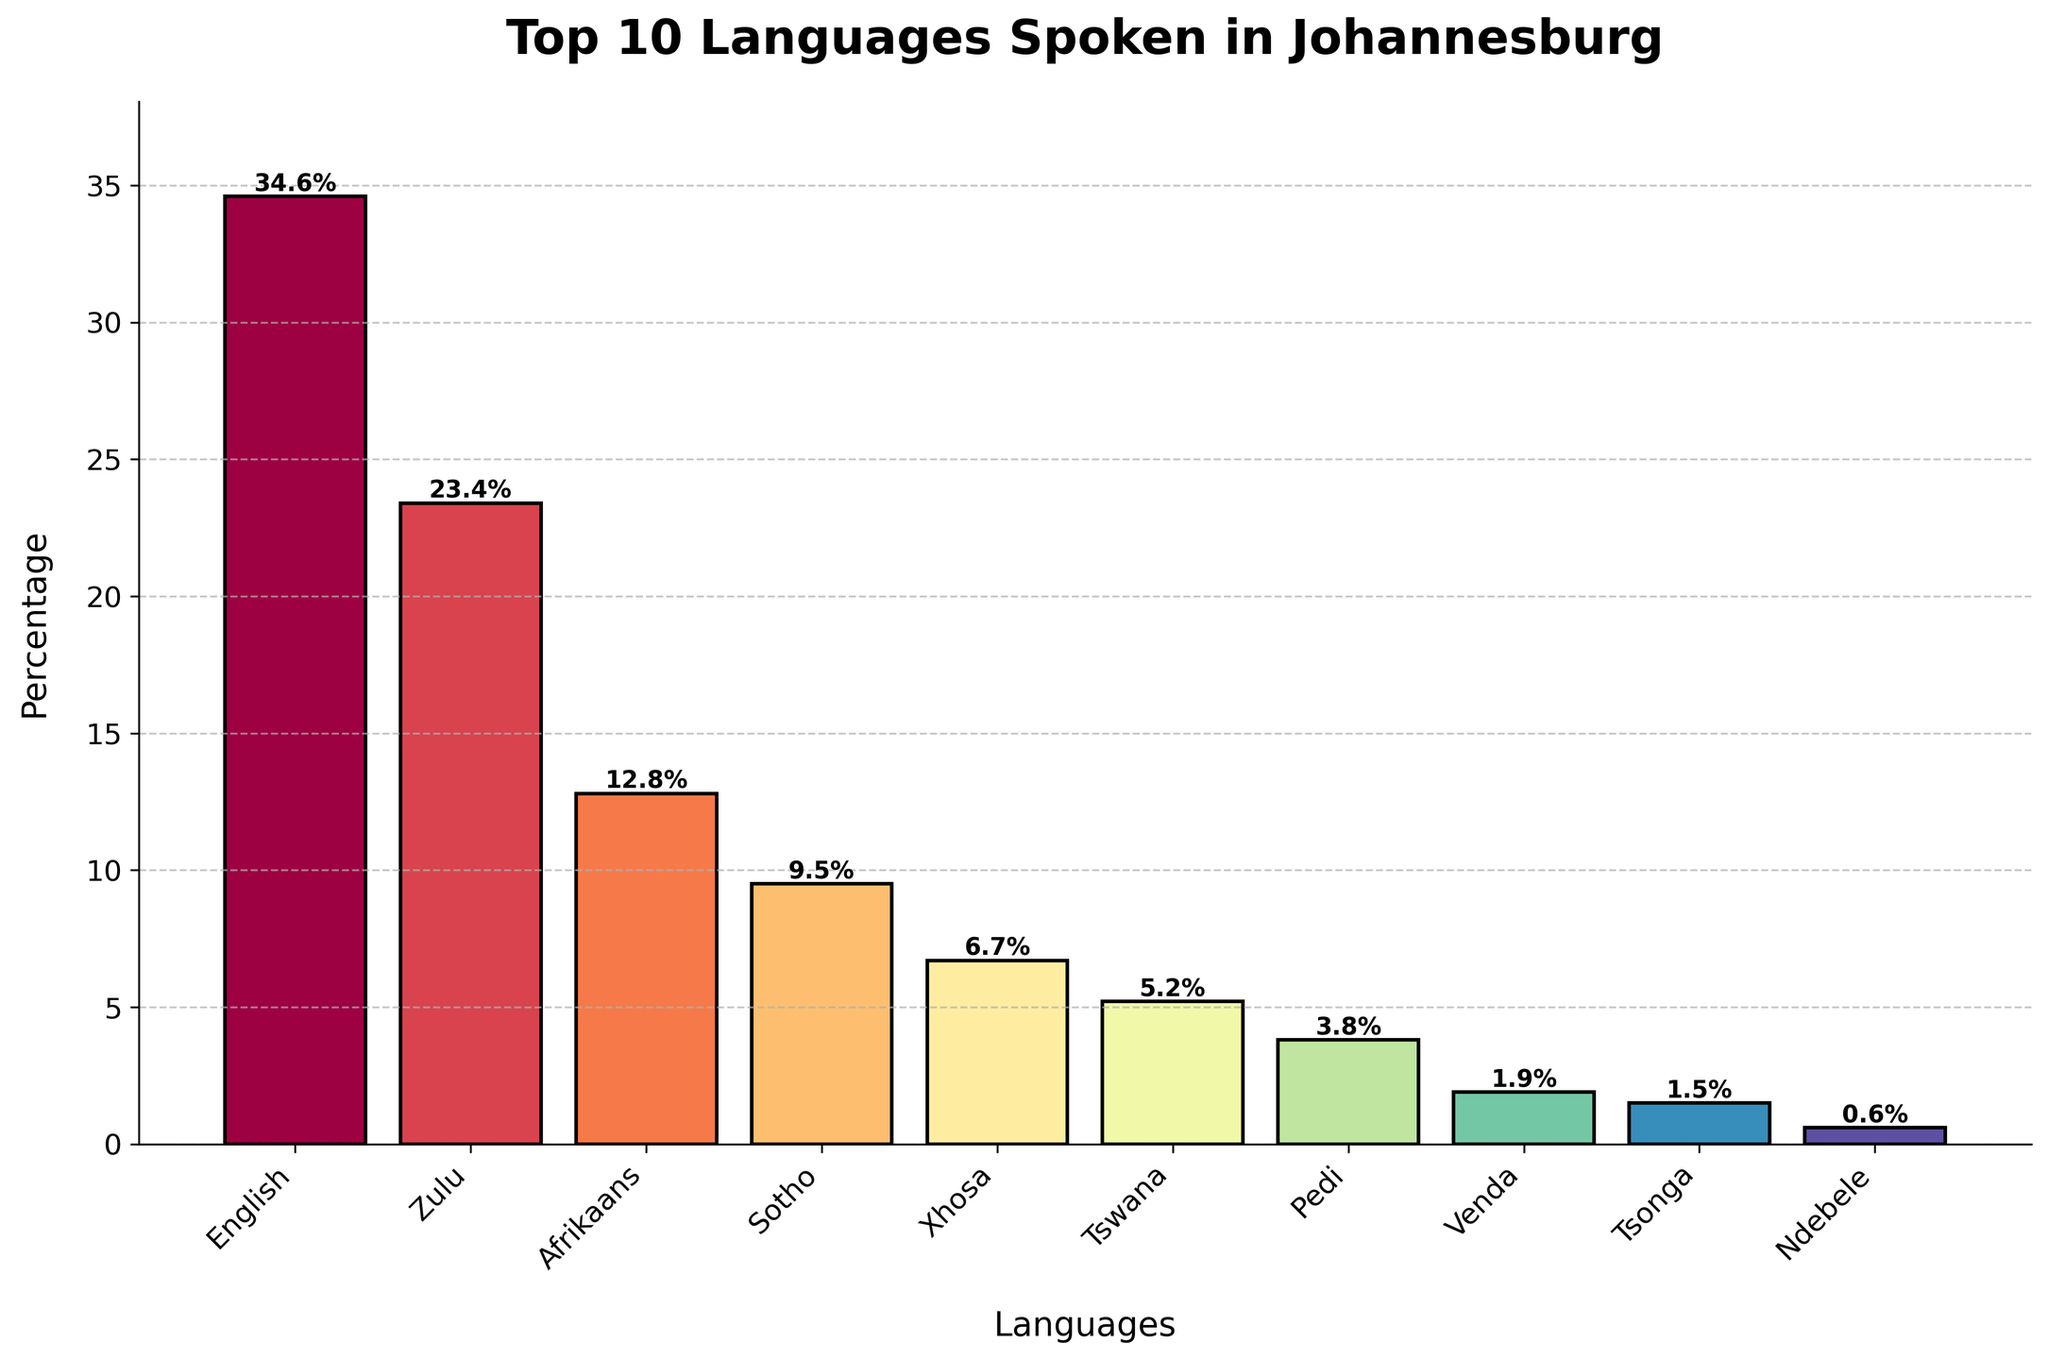Which language has the highest percentage of speakers in Johannesburg? The tallest bar in the chart represents the language with the highest percentage of speakers. The bar labeled "English" reaches the highest point, indicating it has the highest percentage.
Answer: English What is the combined percentage of Zulu, Sotho, and Tswana speakers? Sum the percentages for Zulu (23.4), Sotho (9.5), and Tswana (5.2): 23.4 + 9.5 + 5.2 = 38.1
Answer: 38.1 Which two languages have the smallest difference in their percentage of speakers? Look for the bars whose heights are closest to each other. Pedi (3.8) and Venda (1.9) have a difference of 1.9 (3.8 - 1.9), which is smaller than the differences between other pairs.
Answer: Pedi and Venda Is the percentage of Afrikaans speakers greater than the percentage of Xhosa speakers? Compare the heights of the bars for Afrikaans (12.8) and Xhosa (6.7). The Afrikaans bar is taller.
Answer: Yes What is the average percentage of the top three languages? Sum the percentages of the top three languages (English: 34.6, Zulu: 23.4, Afrikaans: 12.8) and divide by 3: (34.6 + 23.4 + 12.8) / 3 = 23.6
Answer: 23.6 How many languages have a percentage of speakers less than 5%? Count the bars whose height corresponds to a percentage less than 5%. There are four such languages: Pedi (3.8), Venda (1.9), Tsonga (1.5), Ndebele (0.6).
Answer: Four If the bars representing Zulu and Sotho were combined into one category, what would be the new percentage, and how would it compare to English? Combine the percentages for Zulu (23.4) and Sotho (9.5) to get 32.9. Compare this with the percentage for English (34.6). 32.9 is less than 34.6.
Answer: 32.9; Less than English Is the sum of percentages for the bottom five languages (Tswana, Pedi, Venda, Tsonga, Ndebele) greater than the percentage for Afrikaans? Sum the percentages of the bottom five languages: 5.2 + 3.8 + 1.9 + 1.5 + 0.6 = 13. Add up to 13 which is greater than Afrikaans (12.8).
Answer: Yes Which language represents less than 2% of the speakers in Johannesburg? Identify the bar that reaches just under the 2% mark. Both Venda (1.9) and Tsonga (1.5) fall into this category.
Answer: Venda and Tsonga 